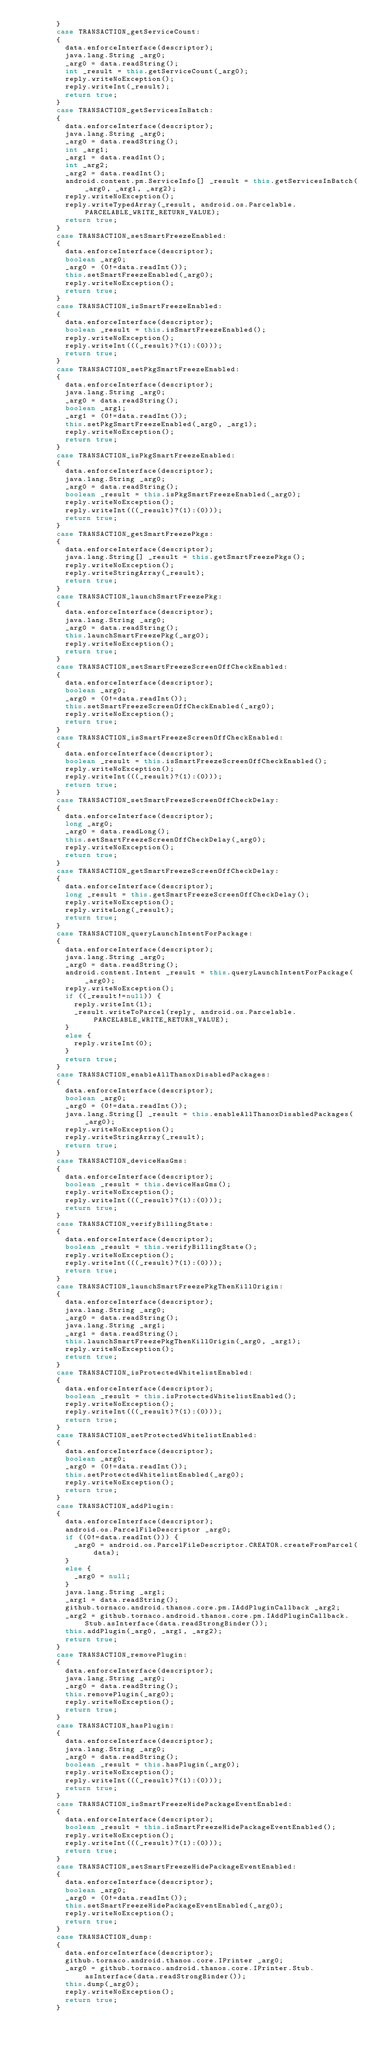Convert code to text. <code><loc_0><loc_0><loc_500><loc_500><_Java_>        }
        case TRANSACTION_getServiceCount:
        {
          data.enforceInterface(descriptor);
          java.lang.String _arg0;
          _arg0 = data.readString();
          int _result = this.getServiceCount(_arg0);
          reply.writeNoException();
          reply.writeInt(_result);
          return true;
        }
        case TRANSACTION_getServicesInBatch:
        {
          data.enforceInterface(descriptor);
          java.lang.String _arg0;
          _arg0 = data.readString();
          int _arg1;
          _arg1 = data.readInt();
          int _arg2;
          _arg2 = data.readInt();
          android.content.pm.ServiceInfo[] _result = this.getServicesInBatch(_arg0, _arg1, _arg2);
          reply.writeNoException();
          reply.writeTypedArray(_result, android.os.Parcelable.PARCELABLE_WRITE_RETURN_VALUE);
          return true;
        }
        case TRANSACTION_setSmartFreezeEnabled:
        {
          data.enforceInterface(descriptor);
          boolean _arg0;
          _arg0 = (0!=data.readInt());
          this.setSmartFreezeEnabled(_arg0);
          reply.writeNoException();
          return true;
        }
        case TRANSACTION_isSmartFreezeEnabled:
        {
          data.enforceInterface(descriptor);
          boolean _result = this.isSmartFreezeEnabled();
          reply.writeNoException();
          reply.writeInt(((_result)?(1):(0)));
          return true;
        }
        case TRANSACTION_setPkgSmartFreezeEnabled:
        {
          data.enforceInterface(descriptor);
          java.lang.String _arg0;
          _arg0 = data.readString();
          boolean _arg1;
          _arg1 = (0!=data.readInt());
          this.setPkgSmartFreezeEnabled(_arg0, _arg1);
          reply.writeNoException();
          return true;
        }
        case TRANSACTION_isPkgSmartFreezeEnabled:
        {
          data.enforceInterface(descriptor);
          java.lang.String _arg0;
          _arg0 = data.readString();
          boolean _result = this.isPkgSmartFreezeEnabled(_arg0);
          reply.writeNoException();
          reply.writeInt(((_result)?(1):(0)));
          return true;
        }
        case TRANSACTION_getSmartFreezePkgs:
        {
          data.enforceInterface(descriptor);
          java.lang.String[] _result = this.getSmartFreezePkgs();
          reply.writeNoException();
          reply.writeStringArray(_result);
          return true;
        }
        case TRANSACTION_launchSmartFreezePkg:
        {
          data.enforceInterface(descriptor);
          java.lang.String _arg0;
          _arg0 = data.readString();
          this.launchSmartFreezePkg(_arg0);
          reply.writeNoException();
          return true;
        }
        case TRANSACTION_setSmartFreezeScreenOffCheckEnabled:
        {
          data.enforceInterface(descriptor);
          boolean _arg0;
          _arg0 = (0!=data.readInt());
          this.setSmartFreezeScreenOffCheckEnabled(_arg0);
          reply.writeNoException();
          return true;
        }
        case TRANSACTION_isSmartFreezeScreenOffCheckEnabled:
        {
          data.enforceInterface(descriptor);
          boolean _result = this.isSmartFreezeScreenOffCheckEnabled();
          reply.writeNoException();
          reply.writeInt(((_result)?(1):(0)));
          return true;
        }
        case TRANSACTION_setSmartFreezeScreenOffCheckDelay:
        {
          data.enforceInterface(descriptor);
          long _arg0;
          _arg0 = data.readLong();
          this.setSmartFreezeScreenOffCheckDelay(_arg0);
          reply.writeNoException();
          return true;
        }
        case TRANSACTION_getSmartFreezeScreenOffCheckDelay:
        {
          data.enforceInterface(descriptor);
          long _result = this.getSmartFreezeScreenOffCheckDelay();
          reply.writeNoException();
          reply.writeLong(_result);
          return true;
        }
        case TRANSACTION_queryLaunchIntentForPackage:
        {
          data.enforceInterface(descriptor);
          java.lang.String _arg0;
          _arg0 = data.readString();
          android.content.Intent _result = this.queryLaunchIntentForPackage(_arg0);
          reply.writeNoException();
          if ((_result!=null)) {
            reply.writeInt(1);
            _result.writeToParcel(reply, android.os.Parcelable.PARCELABLE_WRITE_RETURN_VALUE);
          }
          else {
            reply.writeInt(0);
          }
          return true;
        }
        case TRANSACTION_enableAllThanoxDisabledPackages:
        {
          data.enforceInterface(descriptor);
          boolean _arg0;
          _arg0 = (0!=data.readInt());
          java.lang.String[] _result = this.enableAllThanoxDisabledPackages(_arg0);
          reply.writeNoException();
          reply.writeStringArray(_result);
          return true;
        }
        case TRANSACTION_deviceHasGms:
        {
          data.enforceInterface(descriptor);
          boolean _result = this.deviceHasGms();
          reply.writeNoException();
          reply.writeInt(((_result)?(1):(0)));
          return true;
        }
        case TRANSACTION_verifyBillingState:
        {
          data.enforceInterface(descriptor);
          boolean _result = this.verifyBillingState();
          reply.writeNoException();
          reply.writeInt(((_result)?(1):(0)));
          return true;
        }
        case TRANSACTION_launchSmartFreezePkgThenKillOrigin:
        {
          data.enforceInterface(descriptor);
          java.lang.String _arg0;
          _arg0 = data.readString();
          java.lang.String _arg1;
          _arg1 = data.readString();
          this.launchSmartFreezePkgThenKillOrigin(_arg0, _arg1);
          reply.writeNoException();
          return true;
        }
        case TRANSACTION_isProtectedWhitelistEnabled:
        {
          data.enforceInterface(descriptor);
          boolean _result = this.isProtectedWhitelistEnabled();
          reply.writeNoException();
          reply.writeInt(((_result)?(1):(0)));
          return true;
        }
        case TRANSACTION_setProtectedWhitelistEnabled:
        {
          data.enforceInterface(descriptor);
          boolean _arg0;
          _arg0 = (0!=data.readInt());
          this.setProtectedWhitelistEnabled(_arg0);
          reply.writeNoException();
          return true;
        }
        case TRANSACTION_addPlugin:
        {
          data.enforceInterface(descriptor);
          android.os.ParcelFileDescriptor _arg0;
          if ((0!=data.readInt())) {
            _arg0 = android.os.ParcelFileDescriptor.CREATOR.createFromParcel(data);
          }
          else {
            _arg0 = null;
          }
          java.lang.String _arg1;
          _arg1 = data.readString();
          github.tornaco.android.thanos.core.pm.IAddPluginCallback _arg2;
          _arg2 = github.tornaco.android.thanos.core.pm.IAddPluginCallback.Stub.asInterface(data.readStrongBinder());
          this.addPlugin(_arg0, _arg1, _arg2);
          return true;
        }
        case TRANSACTION_removePlugin:
        {
          data.enforceInterface(descriptor);
          java.lang.String _arg0;
          _arg0 = data.readString();
          this.removePlugin(_arg0);
          reply.writeNoException();
          return true;
        }
        case TRANSACTION_hasPlugin:
        {
          data.enforceInterface(descriptor);
          java.lang.String _arg0;
          _arg0 = data.readString();
          boolean _result = this.hasPlugin(_arg0);
          reply.writeNoException();
          reply.writeInt(((_result)?(1):(0)));
          return true;
        }
        case TRANSACTION_isSmartFreezeHidePackageEventEnabled:
        {
          data.enforceInterface(descriptor);
          boolean _result = this.isSmartFreezeHidePackageEventEnabled();
          reply.writeNoException();
          reply.writeInt(((_result)?(1):(0)));
          return true;
        }
        case TRANSACTION_setSmartFreezeHidePackageEventEnabled:
        {
          data.enforceInterface(descriptor);
          boolean _arg0;
          _arg0 = (0!=data.readInt());
          this.setSmartFreezeHidePackageEventEnabled(_arg0);
          reply.writeNoException();
          return true;
        }
        case TRANSACTION_dump:
        {
          data.enforceInterface(descriptor);
          github.tornaco.android.thanos.core.IPrinter _arg0;
          _arg0 = github.tornaco.android.thanos.core.IPrinter.Stub.asInterface(data.readStrongBinder());
          this.dump(_arg0);
          reply.writeNoException();
          return true;
        }</code> 